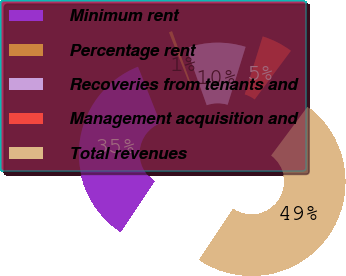Convert chart. <chart><loc_0><loc_0><loc_500><loc_500><pie_chart><fcel>Minimum rent<fcel>Percentage rent<fcel>Recoveries from tenants and<fcel>Management acquisition and<fcel>Total revenues<nl><fcel>34.64%<fcel>0.54%<fcel>10.26%<fcel>5.4%<fcel>49.16%<nl></chart> 